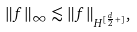Convert formula to latex. <formula><loc_0><loc_0><loc_500><loc_500>\| f \| _ { \infty } \lesssim \| f \| _ { H ^ { [ \frac { d } { 2 } + ] } } ,</formula> 